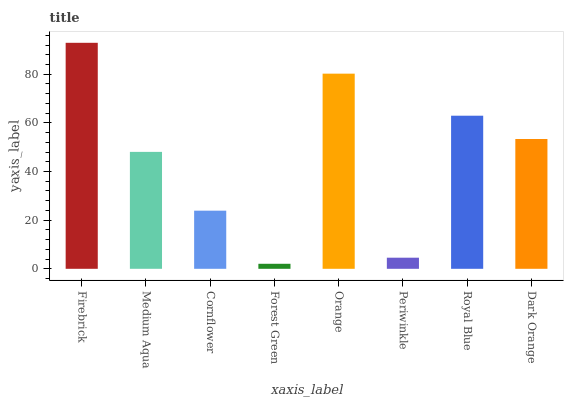Is Forest Green the minimum?
Answer yes or no. Yes. Is Firebrick the maximum?
Answer yes or no. Yes. Is Medium Aqua the minimum?
Answer yes or no. No. Is Medium Aqua the maximum?
Answer yes or no. No. Is Firebrick greater than Medium Aqua?
Answer yes or no. Yes. Is Medium Aqua less than Firebrick?
Answer yes or no. Yes. Is Medium Aqua greater than Firebrick?
Answer yes or no. No. Is Firebrick less than Medium Aqua?
Answer yes or no. No. Is Dark Orange the high median?
Answer yes or no. Yes. Is Medium Aqua the low median?
Answer yes or no. Yes. Is Cornflower the high median?
Answer yes or no. No. Is Royal Blue the low median?
Answer yes or no. No. 